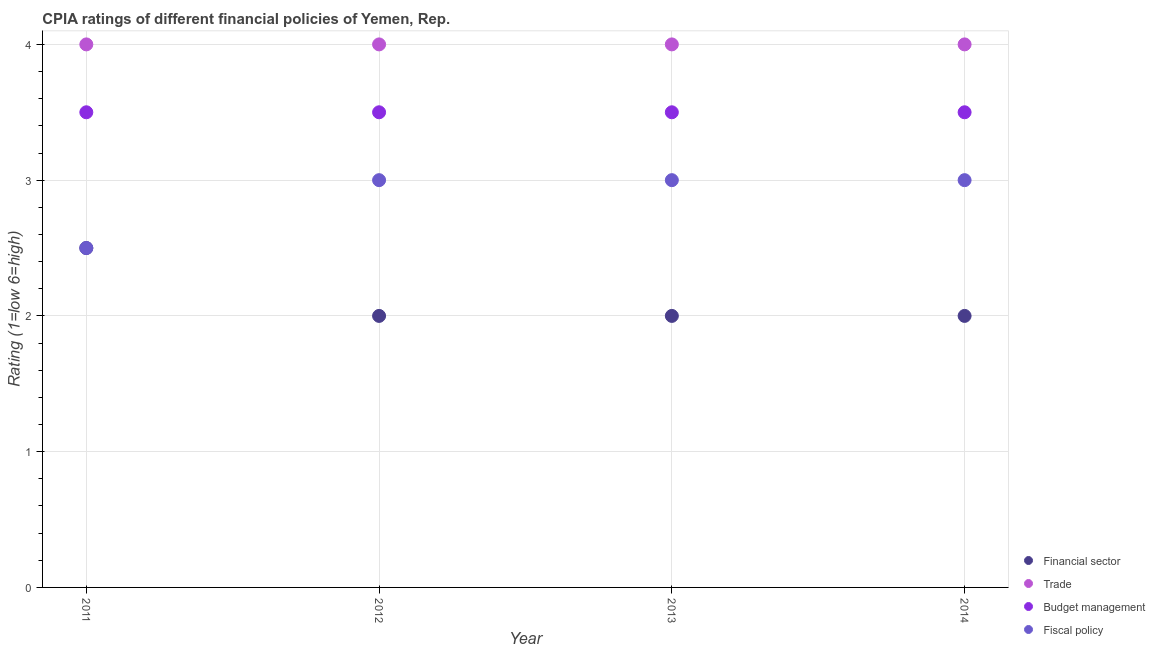How many different coloured dotlines are there?
Your response must be concise. 4. Is the number of dotlines equal to the number of legend labels?
Offer a terse response. Yes. What is the cpia rating of fiscal policy in 2011?
Provide a short and direct response. 2.5. Across all years, what is the maximum cpia rating of budget management?
Give a very brief answer. 3.5. What is the difference between the cpia rating of budget management in 2013 and that in 2014?
Offer a terse response. 0. What is the difference between the cpia rating of budget management in 2014 and the cpia rating of fiscal policy in 2012?
Your answer should be very brief. 0.5. What is the average cpia rating of budget management per year?
Provide a short and direct response. 3.5. In how many years, is the cpia rating of fiscal policy greater than 2.4?
Your answer should be very brief. 4. What is the ratio of the cpia rating of budget management in 2012 to that in 2014?
Your answer should be very brief. 1. What is the difference between the highest and the lowest cpia rating of trade?
Offer a very short reply. 0. Is the sum of the cpia rating of trade in 2012 and 2013 greater than the maximum cpia rating of financial sector across all years?
Ensure brevity in your answer.  Yes. Is it the case that in every year, the sum of the cpia rating of trade and cpia rating of financial sector is greater than the sum of cpia rating of budget management and cpia rating of fiscal policy?
Offer a very short reply. No. Is it the case that in every year, the sum of the cpia rating of financial sector and cpia rating of trade is greater than the cpia rating of budget management?
Offer a very short reply. Yes. Is the cpia rating of trade strictly less than the cpia rating of fiscal policy over the years?
Your response must be concise. No. How many years are there in the graph?
Your response must be concise. 4. Does the graph contain grids?
Provide a succinct answer. Yes. What is the title of the graph?
Your response must be concise. CPIA ratings of different financial policies of Yemen, Rep. Does "Primary education" appear as one of the legend labels in the graph?
Give a very brief answer. No. What is the label or title of the X-axis?
Ensure brevity in your answer.  Year. What is the Rating (1=low 6=high) of Financial sector in 2011?
Your response must be concise. 2.5. What is the Rating (1=low 6=high) of Trade in 2011?
Provide a succinct answer. 4. What is the Rating (1=low 6=high) in Budget management in 2011?
Offer a terse response. 3.5. What is the Rating (1=low 6=high) in Fiscal policy in 2011?
Offer a terse response. 2.5. What is the Rating (1=low 6=high) in Financial sector in 2012?
Make the answer very short. 2. What is the Rating (1=low 6=high) in Budget management in 2012?
Keep it short and to the point. 3.5. What is the Rating (1=low 6=high) of Fiscal policy in 2012?
Provide a succinct answer. 3. What is the Rating (1=low 6=high) of Trade in 2013?
Give a very brief answer. 4. Across all years, what is the maximum Rating (1=low 6=high) of Financial sector?
Your answer should be compact. 2.5. Across all years, what is the maximum Rating (1=low 6=high) in Budget management?
Give a very brief answer. 3.5. Across all years, what is the maximum Rating (1=low 6=high) of Fiscal policy?
Make the answer very short. 3. Across all years, what is the minimum Rating (1=low 6=high) in Trade?
Offer a terse response. 4. Across all years, what is the minimum Rating (1=low 6=high) in Fiscal policy?
Keep it short and to the point. 2.5. What is the total Rating (1=low 6=high) of Financial sector in the graph?
Provide a short and direct response. 8.5. What is the total Rating (1=low 6=high) of Trade in the graph?
Your answer should be very brief. 16. What is the total Rating (1=low 6=high) of Budget management in the graph?
Your answer should be very brief. 14. What is the total Rating (1=low 6=high) in Fiscal policy in the graph?
Offer a terse response. 11.5. What is the difference between the Rating (1=low 6=high) in Financial sector in 2011 and that in 2012?
Your answer should be compact. 0.5. What is the difference between the Rating (1=low 6=high) of Fiscal policy in 2011 and that in 2012?
Provide a succinct answer. -0.5. What is the difference between the Rating (1=low 6=high) in Financial sector in 2011 and that in 2013?
Your answer should be compact. 0.5. What is the difference between the Rating (1=low 6=high) in Trade in 2011 and that in 2013?
Provide a succinct answer. 0. What is the difference between the Rating (1=low 6=high) in Budget management in 2011 and that in 2013?
Offer a very short reply. 0. What is the difference between the Rating (1=low 6=high) of Financial sector in 2011 and that in 2014?
Keep it short and to the point. 0.5. What is the difference between the Rating (1=low 6=high) in Trade in 2011 and that in 2014?
Your answer should be very brief. 0. What is the difference between the Rating (1=low 6=high) of Budget management in 2011 and that in 2014?
Keep it short and to the point. 0. What is the difference between the Rating (1=low 6=high) of Financial sector in 2012 and that in 2013?
Offer a very short reply. 0. What is the difference between the Rating (1=low 6=high) in Budget management in 2012 and that in 2013?
Your answer should be compact. 0. What is the difference between the Rating (1=low 6=high) in Financial sector in 2012 and that in 2014?
Make the answer very short. 0. What is the difference between the Rating (1=low 6=high) in Trade in 2012 and that in 2014?
Keep it short and to the point. 0. What is the difference between the Rating (1=low 6=high) in Budget management in 2012 and that in 2014?
Provide a short and direct response. 0. What is the difference between the Rating (1=low 6=high) in Trade in 2013 and that in 2014?
Offer a terse response. 0. What is the difference between the Rating (1=low 6=high) in Financial sector in 2011 and the Rating (1=low 6=high) in Budget management in 2012?
Provide a succinct answer. -1. What is the difference between the Rating (1=low 6=high) in Financial sector in 2011 and the Rating (1=low 6=high) in Fiscal policy in 2012?
Your response must be concise. -0.5. What is the difference between the Rating (1=low 6=high) in Budget management in 2011 and the Rating (1=low 6=high) in Fiscal policy in 2012?
Your answer should be very brief. 0.5. What is the difference between the Rating (1=low 6=high) in Financial sector in 2011 and the Rating (1=low 6=high) in Fiscal policy in 2013?
Provide a succinct answer. -0.5. What is the difference between the Rating (1=low 6=high) in Trade in 2011 and the Rating (1=low 6=high) in Budget management in 2013?
Offer a terse response. 0.5. What is the difference between the Rating (1=low 6=high) of Trade in 2011 and the Rating (1=low 6=high) of Fiscal policy in 2013?
Your answer should be very brief. 1. What is the difference between the Rating (1=low 6=high) of Financial sector in 2011 and the Rating (1=low 6=high) of Trade in 2014?
Keep it short and to the point. -1.5. What is the difference between the Rating (1=low 6=high) in Financial sector in 2011 and the Rating (1=low 6=high) in Fiscal policy in 2014?
Keep it short and to the point. -0.5. What is the difference between the Rating (1=low 6=high) of Trade in 2011 and the Rating (1=low 6=high) of Budget management in 2014?
Your answer should be compact. 0.5. What is the difference between the Rating (1=low 6=high) in Trade in 2011 and the Rating (1=low 6=high) in Fiscal policy in 2014?
Give a very brief answer. 1. What is the difference between the Rating (1=low 6=high) in Financial sector in 2012 and the Rating (1=low 6=high) in Budget management in 2013?
Make the answer very short. -1.5. What is the difference between the Rating (1=low 6=high) of Financial sector in 2012 and the Rating (1=low 6=high) of Fiscal policy in 2013?
Offer a very short reply. -1. What is the difference between the Rating (1=low 6=high) in Trade in 2012 and the Rating (1=low 6=high) in Budget management in 2013?
Make the answer very short. 0.5. What is the difference between the Rating (1=low 6=high) of Trade in 2012 and the Rating (1=low 6=high) of Fiscal policy in 2013?
Make the answer very short. 1. What is the difference between the Rating (1=low 6=high) in Financial sector in 2012 and the Rating (1=low 6=high) in Trade in 2014?
Provide a short and direct response. -2. What is the difference between the Rating (1=low 6=high) in Financial sector in 2012 and the Rating (1=low 6=high) in Budget management in 2014?
Keep it short and to the point. -1.5. What is the difference between the Rating (1=low 6=high) of Financial sector in 2012 and the Rating (1=low 6=high) of Fiscal policy in 2014?
Give a very brief answer. -1. What is the difference between the Rating (1=low 6=high) of Trade in 2012 and the Rating (1=low 6=high) of Fiscal policy in 2014?
Make the answer very short. 1. What is the difference between the Rating (1=low 6=high) in Financial sector in 2013 and the Rating (1=low 6=high) in Trade in 2014?
Your answer should be compact. -2. What is the difference between the Rating (1=low 6=high) of Financial sector in 2013 and the Rating (1=low 6=high) of Budget management in 2014?
Ensure brevity in your answer.  -1.5. What is the difference between the Rating (1=low 6=high) of Financial sector in 2013 and the Rating (1=low 6=high) of Fiscal policy in 2014?
Your answer should be compact. -1. What is the difference between the Rating (1=low 6=high) of Trade in 2013 and the Rating (1=low 6=high) of Fiscal policy in 2014?
Give a very brief answer. 1. What is the difference between the Rating (1=low 6=high) in Budget management in 2013 and the Rating (1=low 6=high) in Fiscal policy in 2014?
Provide a short and direct response. 0.5. What is the average Rating (1=low 6=high) in Financial sector per year?
Offer a terse response. 2.12. What is the average Rating (1=low 6=high) in Trade per year?
Offer a terse response. 4. What is the average Rating (1=low 6=high) of Fiscal policy per year?
Your answer should be very brief. 2.88. In the year 2011, what is the difference between the Rating (1=low 6=high) in Financial sector and Rating (1=low 6=high) in Budget management?
Ensure brevity in your answer.  -1. In the year 2011, what is the difference between the Rating (1=low 6=high) of Financial sector and Rating (1=low 6=high) of Fiscal policy?
Provide a succinct answer. 0. In the year 2011, what is the difference between the Rating (1=low 6=high) of Trade and Rating (1=low 6=high) of Fiscal policy?
Offer a very short reply. 1.5. In the year 2012, what is the difference between the Rating (1=low 6=high) of Financial sector and Rating (1=low 6=high) of Budget management?
Provide a short and direct response. -1.5. In the year 2012, what is the difference between the Rating (1=low 6=high) of Financial sector and Rating (1=low 6=high) of Fiscal policy?
Provide a succinct answer. -1. In the year 2012, what is the difference between the Rating (1=low 6=high) in Trade and Rating (1=low 6=high) in Fiscal policy?
Your answer should be very brief. 1. In the year 2012, what is the difference between the Rating (1=low 6=high) of Budget management and Rating (1=low 6=high) of Fiscal policy?
Your answer should be compact. 0.5. In the year 2013, what is the difference between the Rating (1=low 6=high) in Financial sector and Rating (1=low 6=high) in Fiscal policy?
Your answer should be compact. -1. In the year 2013, what is the difference between the Rating (1=low 6=high) in Trade and Rating (1=low 6=high) in Budget management?
Your answer should be compact. 0.5. In the year 2013, what is the difference between the Rating (1=low 6=high) in Budget management and Rating (1=low 6=high) in Fiscal policy?
Ensure brevity in your answer.  0.5. In the year 2014, what is the difference between the Rating (1=low 6=high) of Financial sector and Rating (1=low 6=high) of Trade?
Offer a very short reply. -2. In the year 2014, what is the difference between the Rating (1=low 6=high) in Financial sector and Rating (1=low 6=high) in Fiscal policy?
Your answer should be very brief. -1. In the year 2014, what is the difference between the Rating (1=low 6=high) in Trade and Rating (1=low 6=high) in Fiscal policy?
Your response must be concise. 1. What is the ratio of the Rating (1=low 6=high) in Financial sector in 2011 to that in 2012?
Provide a succinct answer. 1.25. What is the ratio of the Rating (1=low 6=high) of Budget management in 2011 to that in 2012?
Your answer should be compact. 1. What is the ratio of the Rating (1=low 6=high) of Fiscal policy in 2011 to that in 2013?
Ensure brevity in your answer.  0.83. What is the ratio of the Rating (1=low 6=high) of Budget management in 2011 to that in 2014?
Offer a very short reply. 1. What is the ratio of the Rating (1=low 6=high) in Fiscal policy in 2011 to that in 2014?
Give a very brief answer. 0.83. What is the ratio of the Rating (1=low 6=high) of Financial sector in 2012 to that in 2013?
Offer a terse response. 1. What is the ratio of the Rating (1=low 6=high) of Trade in 2012 to that in 2013?
Give a very brief answer. 1. What is the ratio of the Rating (1=low 6=high) in Budget management in 2012 to that in 2013?
Offer a terse response. 1. What is the ratio of the Rating (1=low 6=high) of Financial sector in 2012 to that in 2014?
Offer a terse response. 1. What is the ratio of the Rating (1=low 6=high) of Trade in 2012 to that in 2014?
Ensure brevity in your answer.  1. What is the ratio of the Rating (1=low 6=high) of Budget management in 2012 to that in 2014?
Your answer should be compact. 1. What is the ratio of the Rating (1=low 6=high) of Fiscal policy in 2012 to that in 2014?
Ensure brevity in your answer.  1. What is the ratio of the Rating (1=low 6=high) of Trade in 2013 to that in 2014?
Offer a terse response. 1. What is the ratio of the Rating (1=low 6=high) of Budget management in 2013 to that in 2014?
Your response must be concise. 1. What is the difference between the highest and the second highest Rating (1=low 6=high) of Financial sector?
Make the answer very short. 0.5. What is the difference between the highest and the second highest Rating (1=low 6=high) in Trade?
Provide a short and direct response. 0. What is the difference between the highest and the second highest Rating (1=low 6=high) in Budget management?
Give a very brief answer. 0. What is the difference between the highest and the lowest Rating (1=low 6=high) of Trade?
Your answer should be very brief. 0. What is the difference between the highest and the lowest Rating (1=low 6=high) in Budget management?
Give a very brief answer. 0. What is the difference between the highest and the lowest Rating (1=low 6=high) of Fiscal policy?
Offer a terse response. 0.5. 